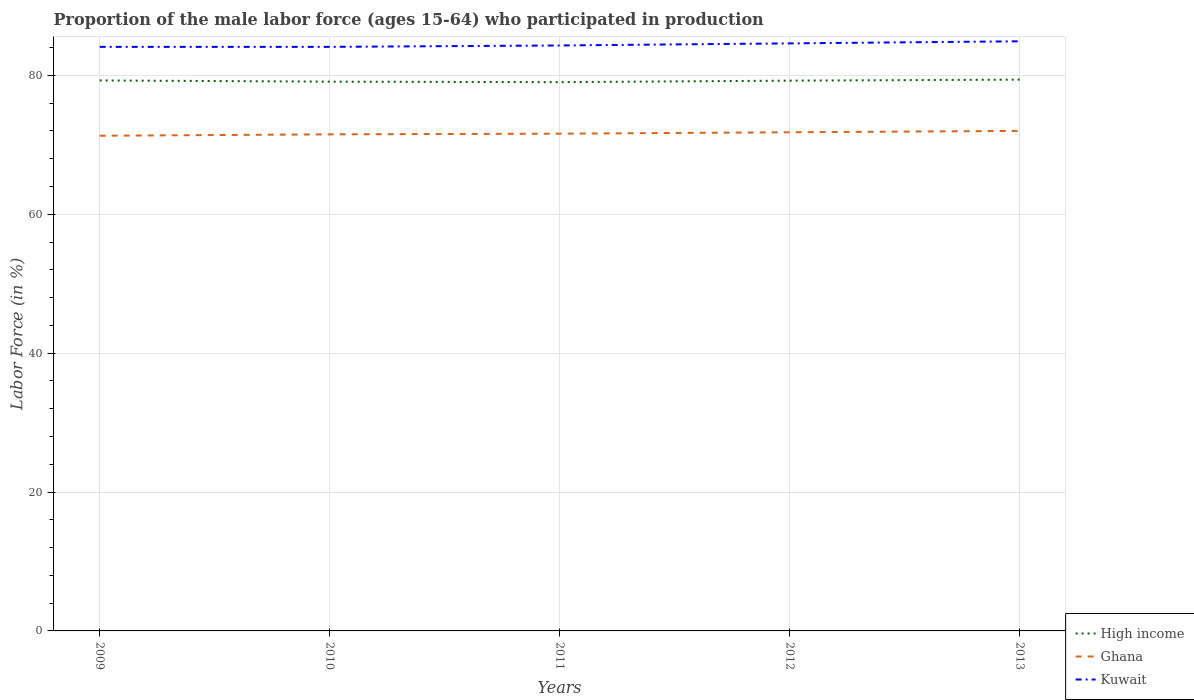Across all years, what is the maximum proportion of the male labor force who participated in production in Kuwait?
Make the answer very short. 84.1. What is the total proportion of the male labor force who participated in production in Ghana in the graph?
Offer a terse response. -0.3. What is the difference between the highest and the second highest proportion of the male labor force who participated in production in High income?
Offer a very short reply. 0.37. Is the proportion of the male labor force who participated in production in Kuwait strictly greater than the proportion of the male labor force who participated in production in High income over the years?
Provide a succinct answer. No. How many lines are there?
Ensure brevity in your answer.  3. How many years are there in the graph?
Your answer should be very brief. 5. Does the graph contain grids?
Make the answer very short. Yes. Where does the legend appear in the graph?
Offer a very short reply. Bottom right. How many legend labels are there?
Your answer should be very brief. 3. What is the title of the graph?
Make the answer very short. Proportion of the male labor force (ages 15-64) who participated in production. What is the label or title of the X-axis?
Provide a short and direct response. Years. What is the label or title of the Y-axis?
Your answer should be compact. Labor Force (in %). What is the Labor Force (in %) in High income in 2009?
Your answer should be compact. 79.26. What is the Labor Force (in %) of Ghana in 2009?
Your answer should be compact. 71.3. What is the Labor Force (in %) of Kuwait in 2009?
Provide a short and direct response. 84.1. What is the Labor Force (in %) in High income in 2010?
Your answer should be compact. 79.09. What is the Labor Force (in %) in Ghana in 2010?
Offer a very short reply. 71.5. What is the Labor Force (in %) in Kuwait in 2010?
Provide a short and direct response. 84.1. What is the Labor Force (in %) of High income in 2011?
Your answer should be very brief. 79.02. What is the Labor Force (in %) of Ghana in 2011?
Keep it short and to the point. 71.6. What is the Labor Force (in %) of Kuwait in 2011?
Your answer should be compact. 84.3. What is the Labor Force (in %) in High income in 2012?
Keep it short and to the point. 79.23. What is the Labor Force (in %) in Ghana in 2012?
Provide a short and direct response. 71.8. What is the Labor Force (in %) of Kuwait in 2012?
Provide a succinct answer. 84.6. What is the Labor Force (in %) in High income in 2013?
Your answer should be very brief. 79.38. What is the Labor Force (in %) of Kuwait in 2013?
Offer a terse response. 84.9. Across all years, what is the maximum Labor Force (in %) in High income?
Your answer should be compact. 79.38. Across all years, what is the maximum Labor Force (in %) of Ghana?
Your answer should be very brief. 72. Across all years, what is the maximum Labor Force (in %) in Kuwait?
Your answer should be compact. 84.9. Across all years, what is the minimum Labor Force (in %) of High income?
Your answer should be very brief. 79.02. Across all years, what is the minimum Labor Force (in %) in Ghana?
Your response must be concise. 71.3. Across all years, what is the minimum Labor Force (in %) in Kuwait?
Keep it short and to the point. 84.1. What is the total Labor Force (in %) of High income in the graph?
Your answer should be compact. 395.98. What is the total Labor Force (in %) in Ghana in the graph?
Your response must be concise. 358.2. What is the total Labor Force (in %) in Kuwait in the graph?
Your response must be concise. 422. What is the difference between the Labor Force (in %) of High income in 2009 and that in 2010?
Your answer should be compact. 0.17. What is the difference between the Labor Force (in %) in Ghana in 2009 and that in 2010?
Offer a very short reply. -0.2. What is the difference between the Labor Force (in %) in High income in 2009 and that in 2011?
Give a very brief answer. 0.25. What is the difference between the Labor Force (in %) in High income in 2009 and that in 2012?
Your answer should be very brief. 0.03. What is the difference between the Labor Force (in %) in High income in 2009 and that in 2013?
Give a very brief answer. -0.12. What is the difference between the Labor Force (in %) in Ghana in 2009 and that in 2013?
Keep it short and to the point. -0.7. What is the difference between the Labor Force (in %) of High income in 2010 and that in 2011?
Ensure brevity in your answer.  0.07. What is the difference between the Labor Force (in %) in Ghana in 2010 and that in 2011?
Give a very brief answer. -0.1. What is the difference between the Labor Force (in %) of Kuwait in 2010 and that in 2011?
Your answer should be very brief. -0.2. What is the difference between the Labor Force (in %) of High income in 2010 and that in 2012?
Ensure brevity in your answer.  -0.14. What is the difference between the Labor Force (in %) in Kuwait in 2010 and that in 2012?
Provide a short and direct response. -0.5. What is the difference between the Labor Force (in %) in High income in 2010 and that in 2013?
Your answer should be very brief. -0.29. What is the difference between the Labor Force (in %) in Ghana in 2010 and that in 2013?
Provide a succinct answer. -0.5. What is the difference between the Labor Force (in %) in High income in 2011 and that in 2012?
Your response must be concise. -0.22. What is the difference between the Labor Force (in %) of Ghana in 2011 and that in 2012?
Make the answer very short. -0.2. What is the difference between the Labor Force (in %) in Kuwait in 2011 and that in 2012?
Make the answer very short. -0.3. What is the difference between the Labor Force (in %) in High income in 2011 and that in 2013?
Make the answer very short. -0.37. What is the difference between the Labor Force (in %) of Kuwait in 2011 and that in 2013?
Offer a terse response. -0.6. What is the difference between the Labor Force (in %) of High income in 2012 and that in 2013?
Your response must be concise. -0.15. What is the difference between the Labor Force (in %) in Ghana in 2012 and that in 2013?
Your response must be concise. -0.2. What is the difference between the Labor Force (in %) of High income in 2009 and the Labor Force (in %) of Ghana in 2010?
Offer a very short reply. 7.76. What is the difference between the Labor Force (in %) in High income in 2009 and the Labor Force (in %) in Kuwait in 2010?
Ensure brevity in your answer.  -4.84. What is the difference between the Labor Force (in %) in Ghana in 2009 and the Labor Force (in %) in Kuwait in 2010?
Keep it short and to the point. -12.8. What is the difference between the Labor Force (in %) of High income in 2009 and the Labor Force (in %) of Ghana in 2011?
Give a very brief answer. 7.66. What is the difference between the Labor Force (in %) of High income in 2009 and the Labor Force (in %) of Kuwait in 2011?
Offer a very short reply. -5.04. What is the difference between the Labor Force (in %) of Ghana in 2009 and the Labor Force (in %) of Kuwait in 2011?
Your answer should be very brief. -13. What is the difference between the Labor Force (in %) of High income in 2009 and the Labor Force (in %) of Ghana in 2012?
Your answer should be very brief. 7.46. What is the difference between the Labor Force (in %) in High income in 2009 and the Labor Force (in %) in Kuwait in 2012?
Make the answer very short. -5.34. What is the difference between the Labor Force (in %) in Ghana in 2009 and the Labor Force (in %) in Kuwait in 2012?
Your answer should be compact. -13.3. What is the difference between the Labor Force (in %) in High income in 2009 and the Labor Force (in %) in Ghana in 2013?
Offer a terse response. 7.26. What is the difference between the Labor Force (in %) of High income in 2009 and the Labor Force (in %) of Kuwait in 2013?
Offer a terse response. -5.64. What is the difference between the Labor Force (in %) of High income in 2010 and the Labor Force (in %) of Ghana in 2011?
Your answer should be very brief. 7.49. What is the difference between the Labor Force (in %) of High income in 2010 and the Labor Force (in %) of Kuwait in 2011?
Your answer should be very brief. -5.21. What is the difference between the Labor Force (in %) of High income in 2010 and the Labor Force (in %) of Ghana in 2012?
Provide a short and direct response. 7.29. What is the difference between the Labor Force (in %) in High income in 2010 and the Labor Force (in %) in Kuwait in 2012?
Your answer should be very brief. -5.51. What is the difference between the Labor Force (in %) of High income in 2010 and the Labor Force (in %) of Ghana in 2013?
Make the answer very short. 7.09. What is the difference between the Labor Force (in %) in High income in 2010 and the Labor Force (in %) in Kuwait in 2013?
Provide a succinct answer. -5.81. What is the difference between the Labor Force (in %) in Ghana in 2010 and the Labor Force (in %) in Kuwait in 2013?
Your answer should be very brief. -13.4. What is the difference between the Labor Force (in %) in High income in 2011 and the Labor Force (in %) in Ghana in 2012?
Your answer should be compact. 7.22. What is the difference between the Labor Force (in %) of High income in 2011 and the Labor Force (in %) of Kuwait in 2012?
Make the answer very short. -5.58. What is the difference between the Labor Force (in %) of High income in 2011 and the Labor Force (in %) of Ghana in 2013?
Your answer should be very brief. 7.02. What is the difference between the Labor Force (in %) in High income in 2011 and the Labor Force (in %) in Kuwait in 2013?
Provide a succinct answer. -5.88. What is the difference between the Labor Force (in %) in High income in 2012 and the Labor Force (in %) in Ghana in 2013?
Provide a succinct answer. 7.23. What is the difference between the Labor Force (in %) of High income in 2012 and the Labor Force (in %) of Kuwait in 2013?
Make the answer very short. -5.67. What is the average Labor Force (in %) in High income per year?
Offer a terse response. 79.2. What is the average Labor Force (in %) in Ghana per year?
Keep it short and to the point. 71.64. What is the average Labor Force (in %) in Kuwait per year?
Provide a succinct answer. 84.4. In the year 2009, what is the difference between the Labor Force (in %) of High income and Labor Force (in %) of Ghana?
Your answer should be very brief. 7.96. In the year 2009, what is the difference between the Labor Force (in %) of High income and Labor Force (in %) of Kuwait?
Offer a very short reply. -4.84. In the year 2010, what is the difference between the Labor Force (in %) in High income and Labor Force (in %) in Ghana?
Provide a short and direct response. 7.59. In the year 2010, what is the difference between the Labor Force (in %) of High income and Labor Force (in %) of Kuwait?
Make the answer very short. -5.01. In the year 2010, what is the difference between the Labor Force (in %) of Ghana and Labor Force (in %) of Kuwait?
Your response must be concise. -12.6. In the year 2011, what is the difference between the Labor Force (in %) of High income and Labor Force (in %) of Ghana?
Offer a very short reply. 7.42. In the year 2011, what is the difference between the Labor Force (in %) in High income and Labor Force (in %) in Kuwait?
Your answer should be compact. -5.28. In the year 2012, what is the difference between the Labor Force (in %) of High income and Labor Force (in %) of Ghana?
Your answer should be very brief. 7.43. In the year 2012, what is the difference between the Labor Force (in %) of High income and Labor Force (in %) of Kuwait?
Keep it short and to the point. -5.37. In the year 2012, what is the difference between the Labor Force (in %) of Ghana and Labor Force (in %) of Kuwait?
Offer a very short reply. -12.8. In the year 2013, what is the difference between the Labor Force (in %) in High income and Labor Force (in %) in Ghana?
Provide a short and direct response. 7.38. In the year 2013, what is the difference between the Labor Force (in %) in High income and Labor Force (in %) in Kuwait?
Make the answer very short. -5.52. In the year 2013, what is the difference between the Labor Force (in %) in Ghana and Labor Force (in %) in Kuwait?
Keep it short and to the point. -12.9. What is the ratio of the Labor Force (in %) in Ghana in 2009 to that in 2010?
Offer a terse response. 1. What is the ratio of the Labor Force (in %) in Kuwait in 2009 to that in 2012?
Your answer should be compact. 0.99. What is the ratio of the Labor Force (in %) of Ghana in 2009 to that in 2013?
Keep it short and to the point. 0.99. What is the ratio of the Labor Force (in %) in Kuwait in 2009 to that in 2013?
Your answer should be very brief. 0.99. What is the ratio of the Labor Force (in %) of Ghana in 2010 to that in 2011?
Your response must be concise. 1. What is the ratio of the Labor Force (in %) of Kuwait in 2010 to that in 2011?
Provide a succinct answer. 1. What is the ratio of the Labor Force (in %) in High income in 2010 to that in 2012?
Offer a terse response. 1. What is the ratio of the Labor Force (in %) of Ghana in 2010 to that in 2012?
Provide a short and direct response. 1. What is the ratio of the Labor Force (in %) in Kuwait in 2010 to that in 2013?
Keep it short and to the point. 0.99. What is the ratio of the Labor Force (in %) of Ghana in 2011 to that in 2012?
Your answer should be compact. 1. What is the ratio of the Labor Force (in %) in High income in 2011 to that in 2013?
Keep it short and to the point. 1. What is the ratio of the Labor Force (in %) in Ghana in 2011 to that in 2013?
Make the answer very short. 0.99. What is the ratio of the Labor Force (in %) of Kuwait in 2011 to that in 2013?
Your answer should be very brief. 0.99. What is the ratio of the Labor Force (in %) in Kuwait in 2012 to that in 2013?
Your response must be concise. 1. What is the difference between the highest and the second highest Labor Force (in %) of High income?
Keep it short and to the point. 0.12. What is the difference between the highest and the second highest Labor Force (in %) of Ghana?
Give a very brief answer. 0.2. What is the difference between the highest and the second highest Labor Force (in %) in Kuwait?
Provide a short and direct response. 0.3. What is the difference between the highest and the lowest Labor Force (in %) in High income?
Make the answer very short. 0.37. What is the difference between the highest and the lowest Labor Force (in %) of Ghana?
Provide a succinct answer. 0.7. 